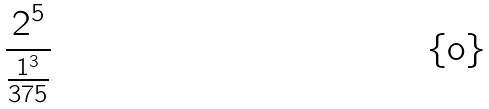Convert formula to latex. <formula><loc_0><loc_0><loc_500><loc_500>\frac { 2 ^ { 5 } } { \frac { 1 ^ { 3 } } { 3 7 5 } }</formula> 